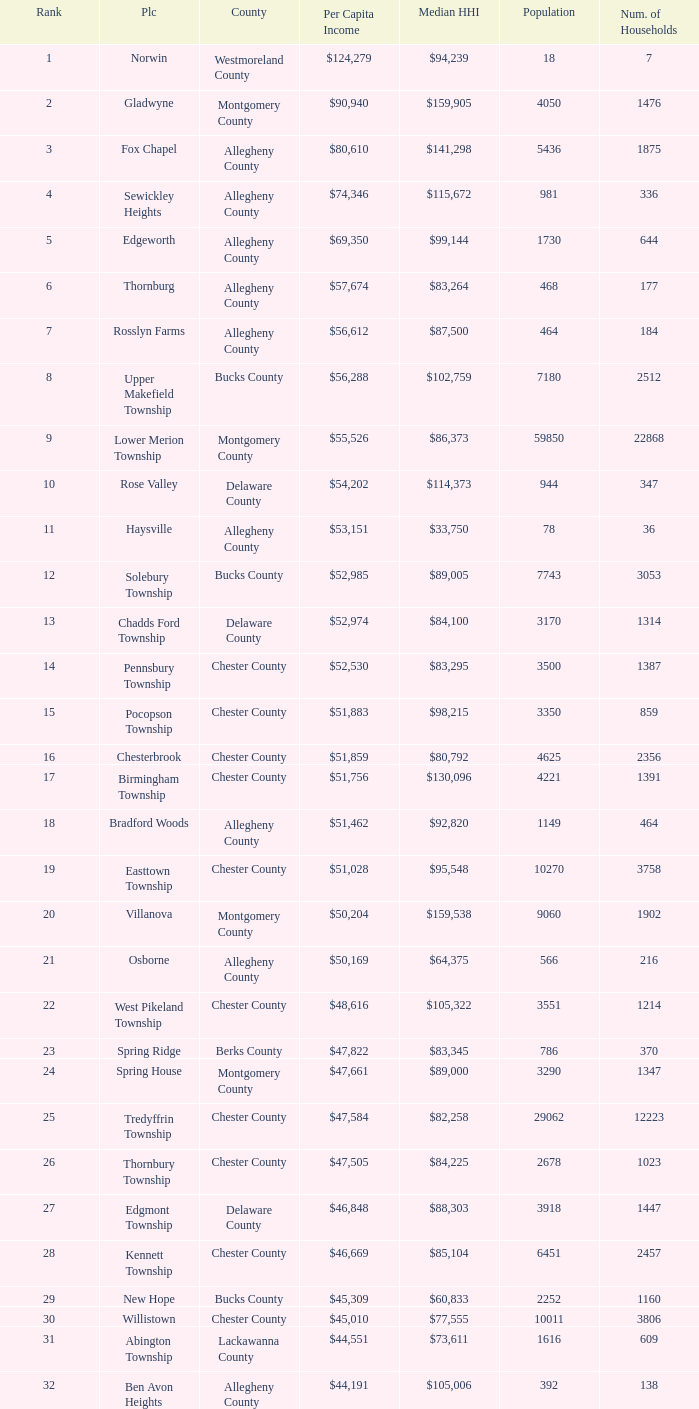Give me the full table as a dictionary. {'header': ['Rank', 'Plc', 'County', 'Per Capita Income', 'Median HHI', 'Population', 'Num. of Households'], 'rows': [['1', 'Norwin', 'Westmoreland County', '$124,279', '$94,239', '18', '7'], ['2', 'Gladwyne', 'Montgomery County', '$90,940', '$159,905', '4050', '1476'], ['3', 'Fox Chapel', 'Allegheny County', '$80,610', '$141,298', '5436', '1875'], ['4', 'Sewickley Heights', 'Allegheny County', '$74,346', '$115,672', '981', '336'], ['5', 'Edgeworth', 'Allegheny County', '$69,350', '$99,144', '1730', '644'], ['6', 'Thornburg', 'Allegheny County', '$57,674', '$83,264', '468', '177'], ['7', 'Rosslyn Farms', 'Allegheny County', '$56,612', '$87,500', '464', '184'], ['8', 'Upper Makefield Township', 'Bucks County', '$56,288', '$102,759', '7180', '2512'], ['9', 'Lower Merion Township', 'Montgomery County', '$55,526', '$86,373', '59850', '22868'], ['10', 'Rose Valley', 'Delaware County', '$54,202', '$114,373', '944', '347'], ['11', 'Haysville', 'Allegheny County', '$53,151', '$33,750', '78', '36'], ['12', 'Solebury Township', 'Bucks County', '$52,985', '$89,005', '7743', '3053'], ['13', 'Chadds Ford Township', 'Delaware County', '$52,974', '$84,100', '3170', '1314'], ['14', 'Pennsbury Township', 'Chester County', '$52,530', '$83,295', '3500', '1387'], ['15', 'Pocopson Township', 'Chester County', '$51,883', '$98,215', '3350', '859'], ['16', 'Chesterbrook', 'Chester County', '$51,859', '$80,792', '4625', '2356'], ['17', 'Birmingham Township', 'Chester County', '$51,756', '$130,096', '4221', '1391'], ['18', 'Bradford Woods', 'Allegheny County', '$51,462', '$92,820', '1149', '464'], ['19', 'Easttown Township', 'Chester County', '$51,028', '$95,548', '10270', '3758'], ['20', 'Villanova', 'Montgomery County', '$50,204', '$159,538', '9060', '1902'], ['21', 'Osborne', 'Allegheny County', '$50,169', '$64,375', '566', '216'], ['22', 'West Pikeland Township', 'Chester County', '$48,616', '$105,322', '3551', '1214'], ['23', 'Spring Ridge', 'Berks County', '$47,822', '$83,345', '786', '370'], ['24', 'Spring House', 'Montgomery County', '$47,661', '$89,000', '3290', '1347'], ['25', 'Tredyffrin Township', 'Chester County', '$47,584', '$82,258', '29062', '12223'], ['26', 'Thornbury Township', 'Chester County', '$47,505', '$84,225', '2678', '1023'], ['27', 'Edgmont Township', 'Delaware County', '$46,848', '$88,303', '3918', '1447'], ['28', 'Kennett Township', 'Chester County', '$46,669', '$85,104', '6451', '2457'], ['29', 'New Hope', 'Bucks County', '$45,309', '$60,833', '2252', '1160'], ['30', 'Willistown', 'Chester County', '$45,010', '$77,555', '10011', '3806'], ['31', 'Abington Township', 'Lackawanna County', '$44,551', '$73,611', '1616', '609'], ['32', 'Ben Avon Heights', 'Allegheny County', '$44,191', '$105,006', '392', '138'], ['33', 'Bala-Cynwyd', 'Montgomery County', '$44,027', '$78,932', '9336', '3726'], ['34', 'Lower Makefield Township', 'Bucks County', '$43,983', '$98,090', '32681', '11706'], ['35', 'Blue Bell', 'Montgomery County', '$43,813', '$94,160', '6395', '2434'], ['36', 'West Vincent Township', 'Chester County', '$43,500', '$92,024', '3170', '1077'], ['37', 'Mount Gretna', 'Lebanon County', '$43,470', '$62,917', '242', '117'], ['38', 'Schuylkill Township', 'Chester County', '$43,379', '$86,092', '6960', '2536'], ['39', 'Fort Washington', 'Montgomery County', '$43,090', '$103,469', '3680', '1161'], ['40', 'Marshall Township', 'Allegheny County', '$42,856', '$102,351', '5996', '1944'], ['41', 'Woodside', 'Bucks County', '$42,653', '$121,151', '2575', '791'], ['42', 'Wrightstown Township', 'Bucks County', '$42,623', '$82,875', '2839', '971'], ['43', 'Upper St.Clair Township', 'Allegheny County', '$42,413', '$87,581', '20053', '6966'], ['44', 'Seven Springs', 'Fayette County', '$42,131', '$48,750', '127', '63'], ['45', 'Charlestown Township', 'Chester County', '$41,878', '$89,813', '4051', '1340'], ['46', 'Lower Gwynedd Township', 'Montgomery County', '$41,868', '$74,351', '10422', '4177'], ['47', 'Whitpain Township', 'Montgomery County', '$41,739', '$88,933', '18562', '6960'], ['48', 'Bell Acres', 'Allegheny County', '$41,202', '$61,094', '1382', '520'], ['49', 'Penn Wynne', 'Montgomery County', '$41,199', '$78,398', '5382', '2072'], ['50', 'East Bradford Township', 'Chester County', '$41,158', '$100,732', '9405', '3076'], ['51', 'Swarthmore', 'Delaware County', '$40,482', '$82,653', '6170', '1993'], ['52', 'Lafayette Hill', 'Montgomery County', '$40,363', '$84,835', '10226', '3783'], ['53', 'Lower Moreland Township', 'Montgomery County', '$40,129', '$82,597', '11281', '4112'], ['54', 'Radnor Township', 'Delaware County', '$39,813', '$74,272', '30878', '10347'], ['55', 'Whitemarsh Township', 'Montgomery County', '$39,785', '$78,630', '16702', '6179'], ['56', 'Upper Providence Township', 'Delaware County', '$39,532', '$71,166', '10509', '4075'], ['57', 'Newtown Township', 'Delaware County', '$39,364', '$65,924', '11700', '4549'], ['58', 'Adams Township', 'Butler County', '$39,204', '$65,357', '6774', '2382'], ['59', 'Edgewood', 'Allegheny County', '$39,188', '$52,153', '3311', '1639'], ['60', 'Dresher', 'Montgomery County', '$38,865', '$99,231', '5610', '1765'], ['61', 'Sewickley Hills', 'Allegheny County', '$38,681', '$79,466', '652', '225'], ['62', 'Exton', 'Chester County', '$38,589', '$68,240', '4267', '2053'], ['63', 'East Marlborough Township', 'Chester County', '$38,090', '$95,812', '6317', '2131'], ['64', 'Doylestown Township', 'Bucks County', '$38,031', '$81,226', '17619', '5999'], ['65', 'Upper Dublin Township', 'Montgomery County', '$37,994', '$80,093', '25878', '9174'], ['66', 'Churchill', 'Allegheny County', '$37,964', '$67,321', '3566', '1519'], ['67', 'Franklin Park', 'Allegheny County', '$37,924', '$87,627', '11364', '3866'], ['68', 'East Goshen Township', 'Chester County', '$37,775', '$64,777', '16824', '7165'], ['69', 'Chester Heights', 'Delaware County', '$37,707', '$70,236', '2481', '1056'], ['70', 'McMurray', 'Washington County', '$37,364', '$81,736', '4726', '1582'], ['71', 'Wyomissing', 'Berks County', '$37,313', '$54,681', '8587', '3359'], ['72', 'Heath Township', 'Jefferson County', '$37,309', '$42,500', '160', '77'], ['73', 'Aleppo Township', 'Allegheny County', '$37,187', '$59,167', '1039', '483'], ['74', 'Westtown Township', 'Chester County', '$36,894', '$85,049', '10352', '3705'], ['75', 'Thompsonville', 'Washington County', '$36,853', '$75,000', '3592', '1228'], ['76', 'Flying Hills', 'Berks County', '$36,822', '$59,596', '1191', '592'], ['77', 'Newlin Township', 'Chester County', '$36,804', '$68,828', '1150', '429'], ['78', 'Wyndmoor', 'Montgomery County', '$36,205', '$72,219', '5601', '2144'], ['79', 'Peters Township', 'Washington County', '$36,159', '$77,442', '17566', '6026'], ['80', 'Ardmore', 'Montgomery County', '$36,111', '$60,966', '12616', '5529'], ['81', 'Clarks Green', 'Lackawanna County', '$35,975', '$61,250', '1630', '616'], ['82', 'London Britain Township', 'Chester County', '$35,761', '$93,521', '2797', '957'], ['83', 'Buckingham Township', 'Bucks County', '$35,735', '$82,376', '16422', '5711'], ['84', 'Devon-Berwyn', 'Chester County', '$35,551', '$74,886', '5067', '1978'], ['85', 'North Abington Township', 'Lackawanna County', '$35,537', '$57,917', '782', '258'], ['86', 'Malvern', 'Chester County', '$35,477', '$62,308', '3059', '1361'], ['87', 'Pine Township', 'Allegheny County', '$35,202', '$85,817', '7683', '2411'], ['88', 'Narberth', 'Montgomery County', '$35,165', '$60,408', '4233', '1904'], ['89', 'West Whiteland Township', 'Chester County', '$35,031', '$71,545', '16499', '6618'], ['90', 'Timber Hills', 'Lebanon County', '$34,974', '$55,938', '329', '157'], ['91', 'Upper Merion Township', 'Montgomery County', '$34,961', '$65,636', '26863', '11575'], ['92', 'Homewood', 'Beaver County', '$34,486', '$33,333', '147', '59'], ['93', 'Newtown Township', 'Bucks County', '$34,335', '$80,532', '18206', '6761'], ['94', 'Tinicum Township', 'Bucks County', '$34,321', '$60,843', '4206', '1674'], ['95', 'Worcester Township', 'Montgomery County', '$34,264', '$77,200', '7789', '2896'], ['96', 'Wyomissing Hills', 'Berks County', '$34,024', '$61,364', '2568', '986'], ['97', 'Woodbourne', 'Bucks County', '$33,821', '$107,913', '3512', '1008'], ['98', 'Concord Township', 'Delaware County', '$33,800', '$85,503', '9933', '3384'], ['99', 'Uwchlan Township', 'Chester County', '$33,785', '$81,985', '16576', '5921']]} What is the median household income for Woodside? $121,151. 